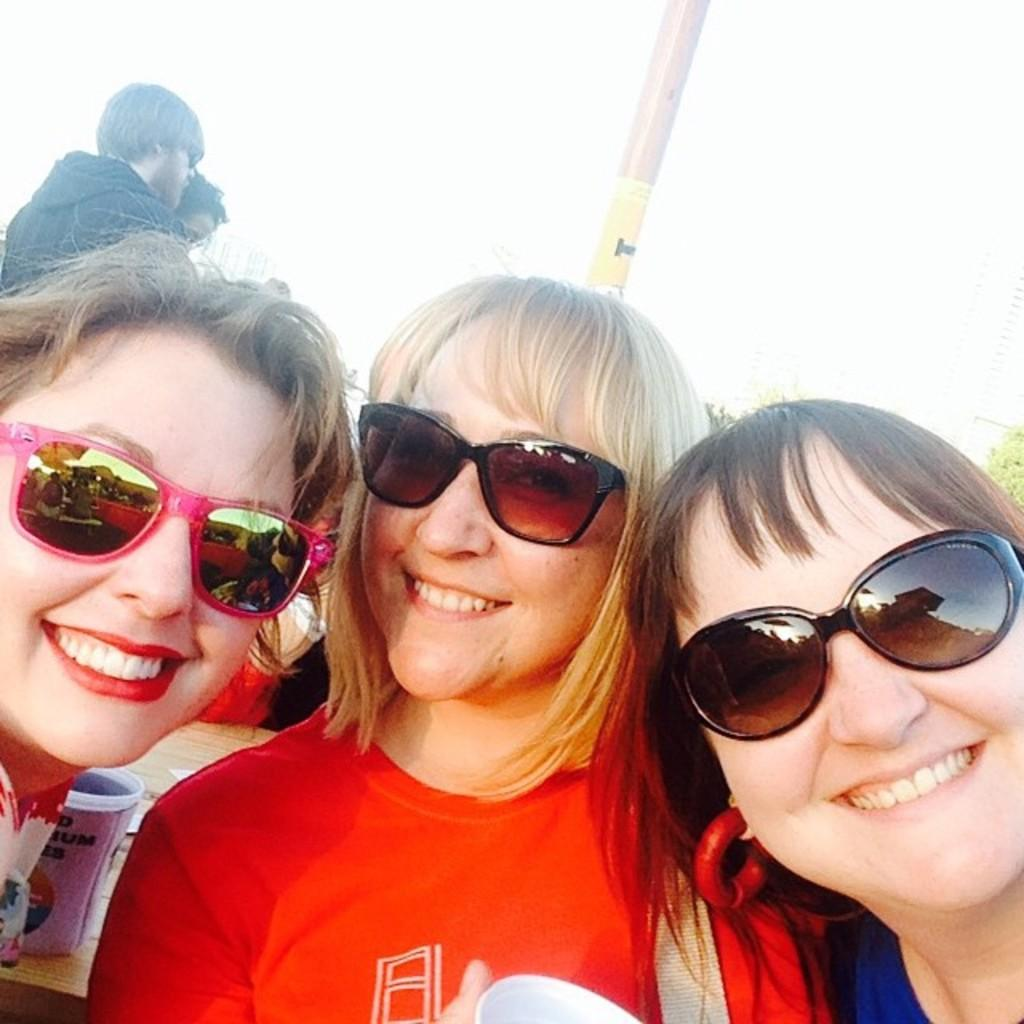How many women are in the foreground of the picture? There are three women in the foreground of the picture. What is happening behind the women? There are people behind the women. What can be seen in the background of the image? There is a pole and trees in the background. How would you describe the weather in the image? The sky is sunny, indicating good weather. Where is the cup located in the image? The cup is on the left side of the image. What type of afternoon is depicted in the image? The image does not depict a specific time of day, so it cannot be determined if it is an afternoon. 